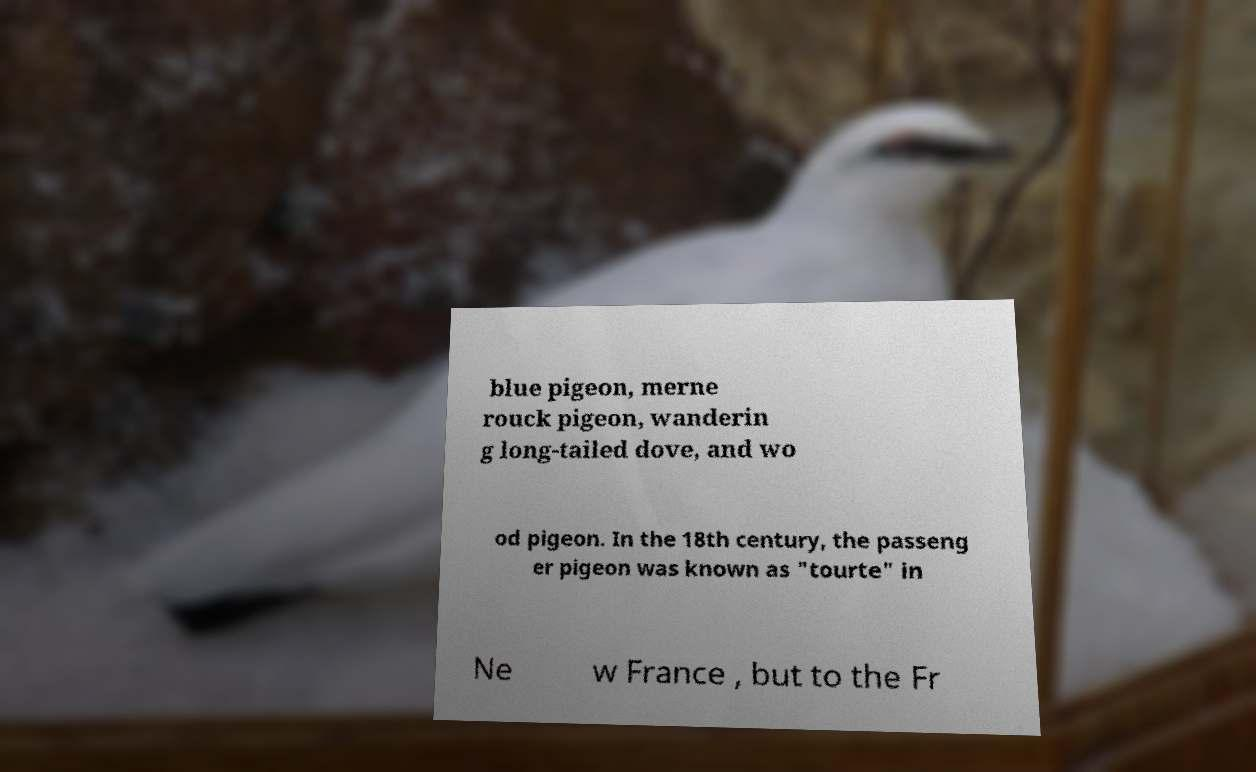Could you extract and type out the text from this image? blue pigeon, merne rouck pigeon, wanderin g long-tailed dove, and wo od pigeon. In the 18th century, the passeng er pigeon was known as "tourte" in Ne w France , but to the Fr 